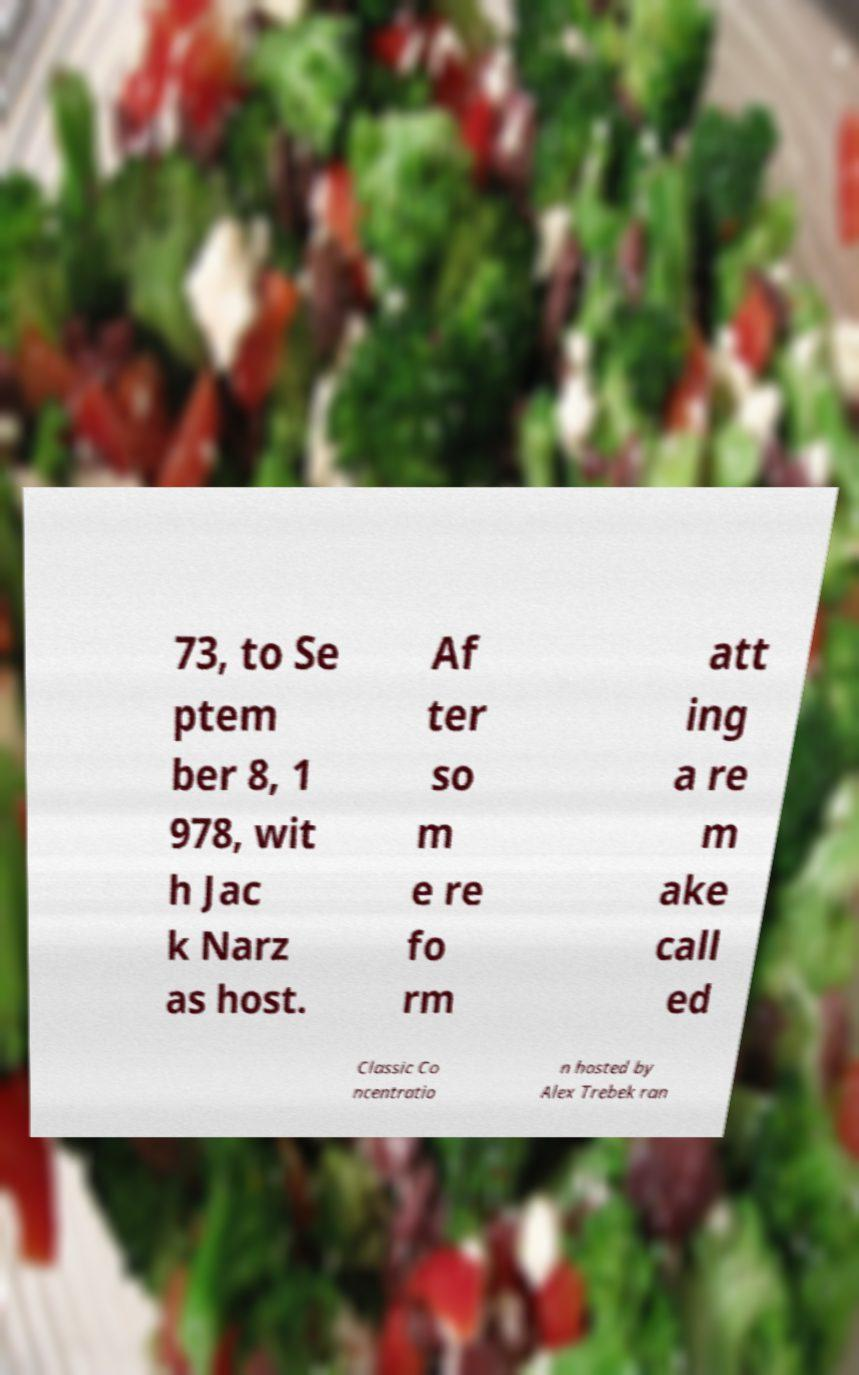There's text embedded in this image that I need extracted. Can you transcribe it verbatim? 73, to Se ptem ber 8, 1 978, wit h Jac k Narz as host. Af ter so m e re fo rm att ing a re m ake call ed Classic Co ncentratio n hosted by Alex Trebek ran 